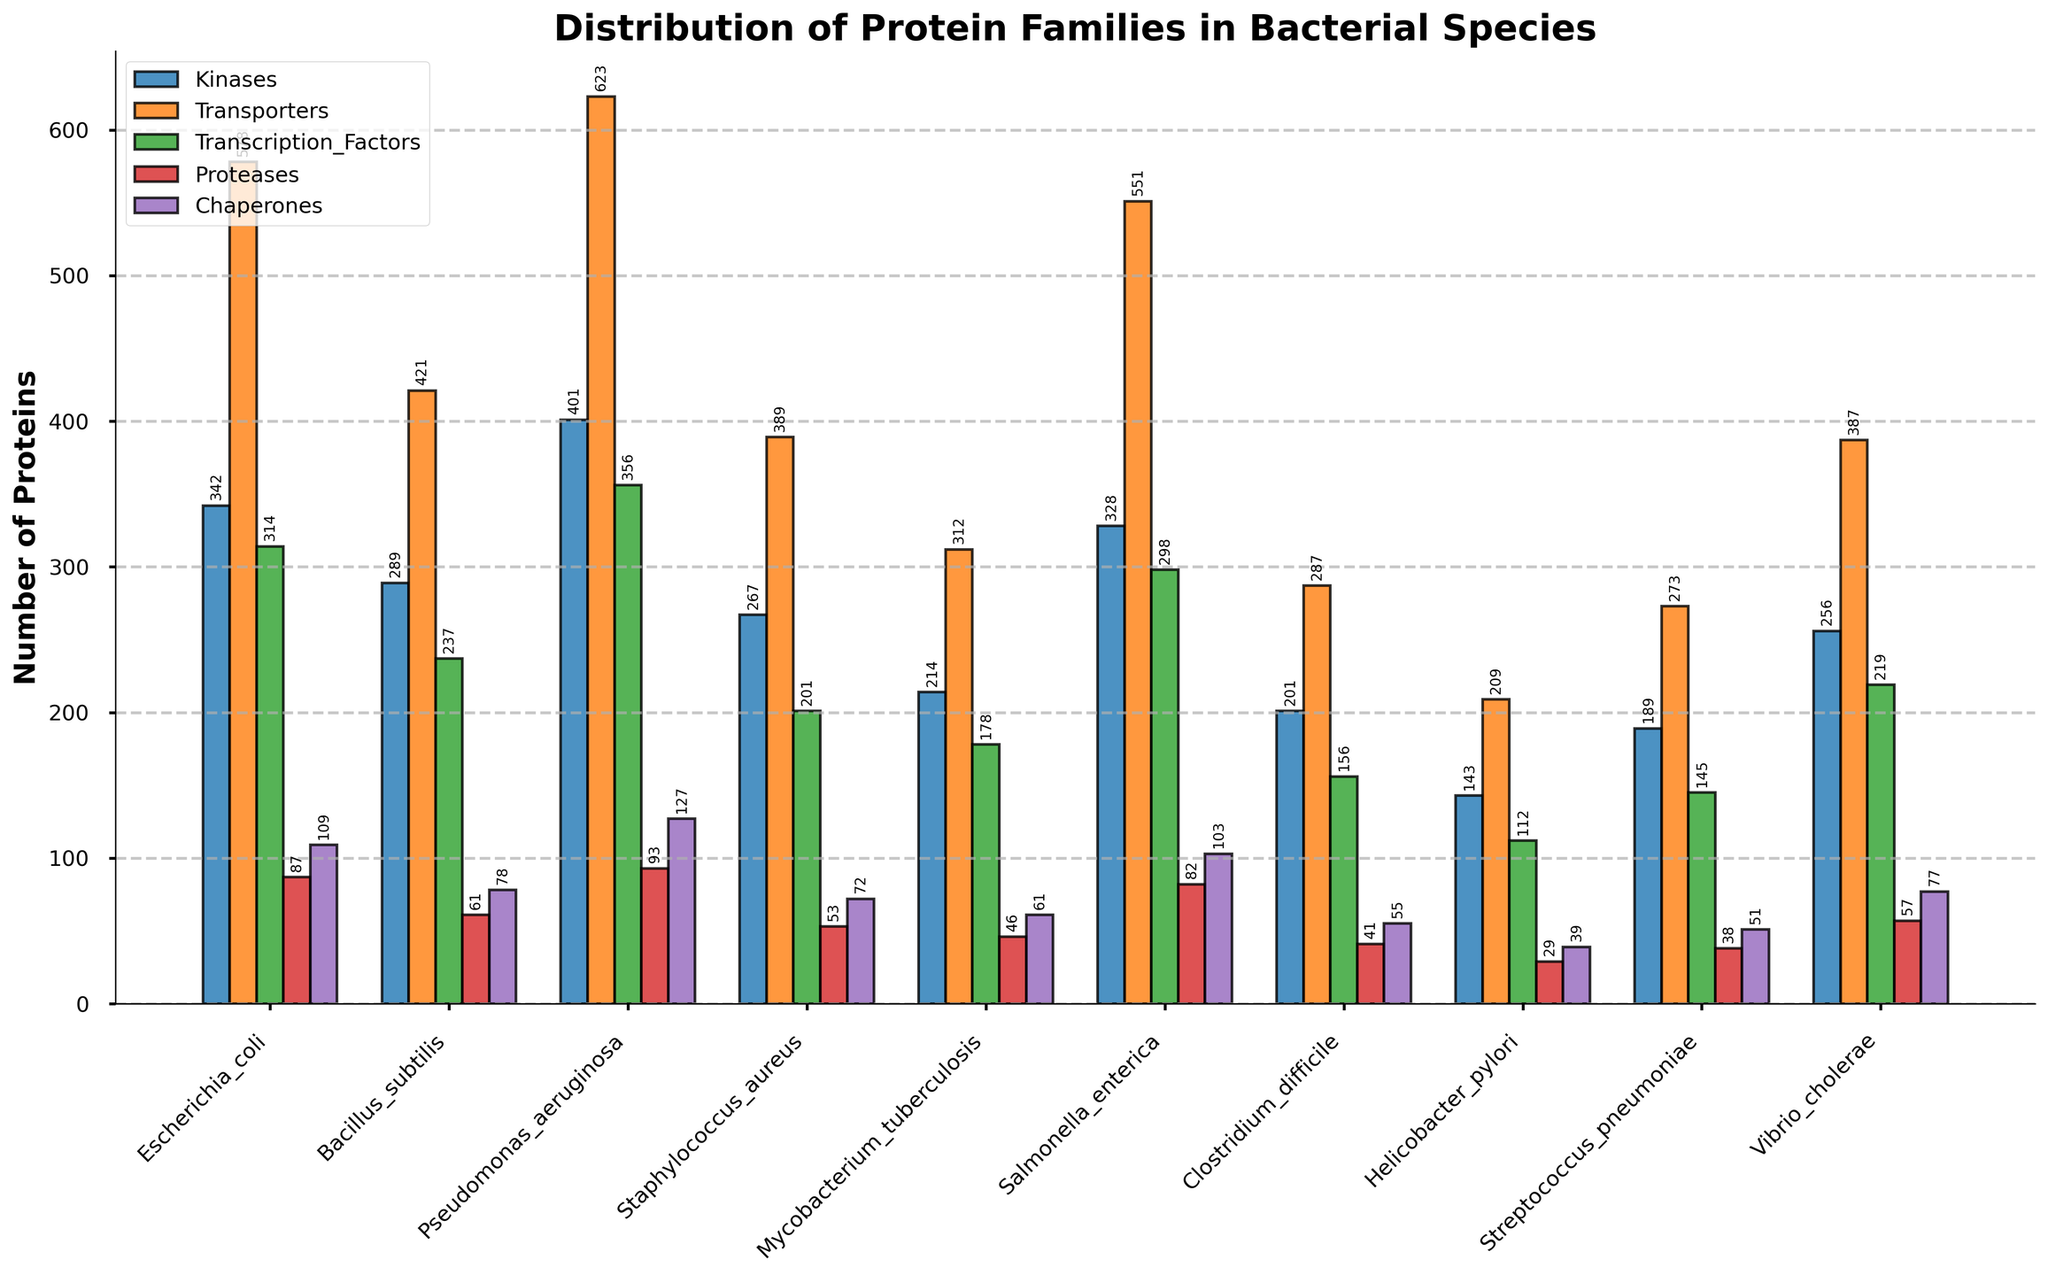Which bacterial species have the highest number of Transporters? The bacterial species with the highest bar in the Transporters category is Pseudomonas aeruginosa.
Answer: Pseudomonas aeruginosa Which bacterial species has fewer Chaperones, Helicobacter pylori or Streptococcus pneumoniae? Compare the heights of the Chaperone bars for both species. Helicobacter pylori has a shorter bar than Streptococcus pneumoniae in the Chaperones category.
Answer: Helicobacter pylori What is the combined total of Kinases and Proteases for Escherichia coli? Sum the number of Kinases (342) and Proteases (87) for Escherichia coli. The total is 342 + 87.
Answer: 429 Which bacterial species has the lowest number of Transcription Factors? The species with the shortest bar in the Transcription Factors category is Helicobacter pylori.
Answer: Helicobacter pylori How many more Transporters does Pseudomonas aeruginosa have compared to Bacillus subtilis? Subtract the number of Transporters in Bacillus subtilis (421) from the number in Pseudomonas aeruginosa (623). The difference is 623 - 421.
Answer: 202 Which protein family has the highest variability across different bacterial species? Observe the range of the bar heights for each protein family across all species. Transporters appear to have the widest range, indicating the highest variability.
Answer: Transporters What are the total numbers of Proteases in Staphylococcus aureus and Vibrio cholerae combined? Add the number of Proteases in Staphylococcus aureus (53) and Vibrio cholerae (57). The total is 53 + 57.
Answer: 110 Which bacterial species has the second highest number of Kinases? Sort the bacterial species by the height of their Kinase bars. The second highest bar for Kinases belongs to Salmonella enterica.
Answer: Salmonella enterica What is the visual trend for the Chaperone family amongst the bacterial species? The Chaperone family consistently has the lowest bars among other protein families across all bacterial species, indicating they have the smallest quantities.
Answer: Lowest across all species 